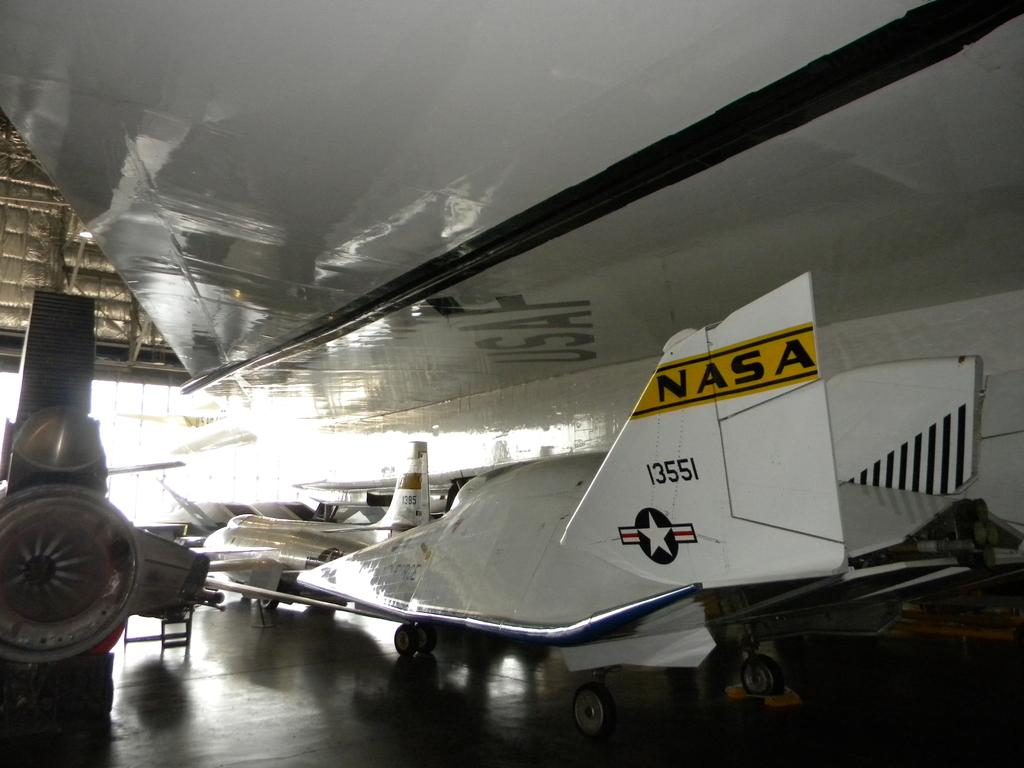<image>
Write a terse but informative summary of the picture. The view of the underside of a USAF plane's wing. 